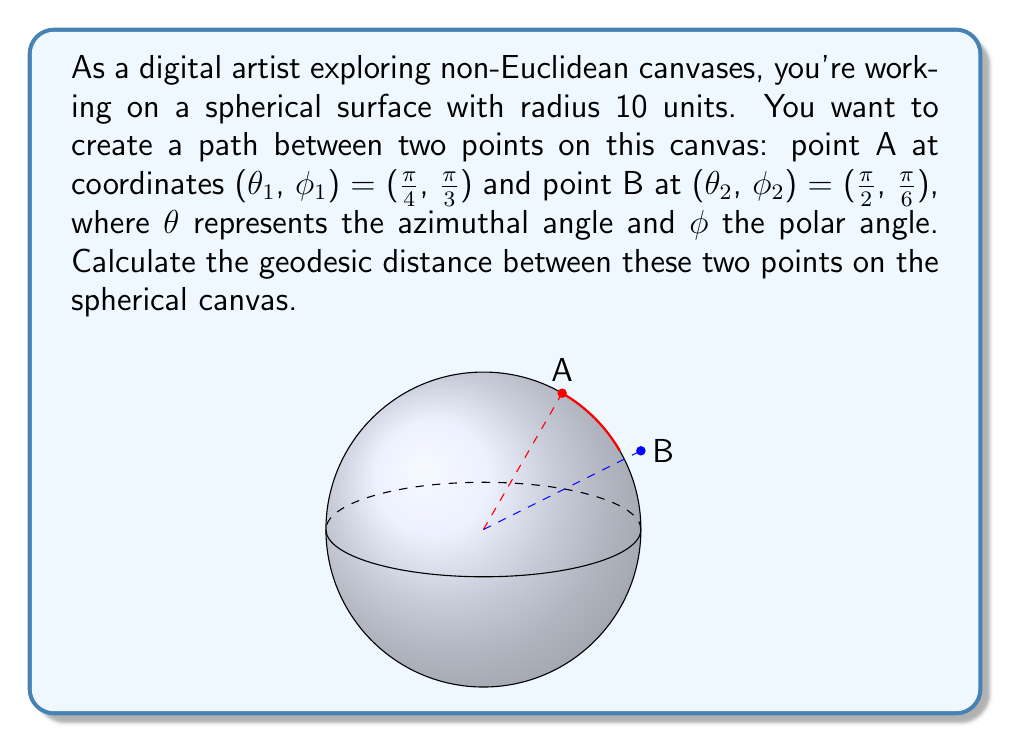Provide a solution to this math problem. To find the geodesic distance between two points on a sphere, we need to use the spherical law of cosines. Let's approach this step-by-step:

1) The spherical law of cosines states:
   $$\cos(c) = \sin(φ₁)\sin(φ₂) + \cos(φ₁)\cos(φ₂)\cos(θ₂ - θ₁)$$
   where c is the central angle between the two points.

2) We're given:
   θ₁ = π/4, φ₁ = π/3
   θ₂ = π/2, φ₂ = π/6

3) Let's substitute these values:
   $$\cos(c) = \sin(π/3)\sin(π/6) + \cos(π/3)\cos(π/6)\cos(π/2 - π/4)$$

4) Simplify:
   $$\cos(c) = (\sqrt{3}/2)(1/2) + (1/2)(\sqrt{3}/2)\cos(π/4)$$

5) We know that $\cos(π/4) = 1/\sqrt{2}$, so:
   $$\cos(c) = \sqrt{3}/4 + (\sqrt{3}/4)(1/\sqrt{2})$$

6) Simplify further:
   $$\cos(c) = \sqrt{3}/4 + \sqrt{6}/8 = (\sqrt{3}\sqrt{2} + \sqrt{6})/(4\sqrt{2})$$

7) Now we need to find c by taking the arccos:
   $$c = \arccos((\sqrt{3}\sqrt{2} + \sqrt{6})/(4\sqrt{2}))$$

8) The geodesic distance d is the arc length, which is the central angle c multiplied by the radius r:
   $$d = rc = 10 \cdot \arccos((\sqrt{3}\sqrt{2} + \sqrt{6})/(4\sqrt{2}))$$

9) Using a calculator or computer, we can evaluate this to get the final answer.
Answer: $10 \cdot \arccos((\sqrt{3}\sqrt{2} + \sqrt{6})/(4\sqrt{2}))$ ≈ 7.0246 units 